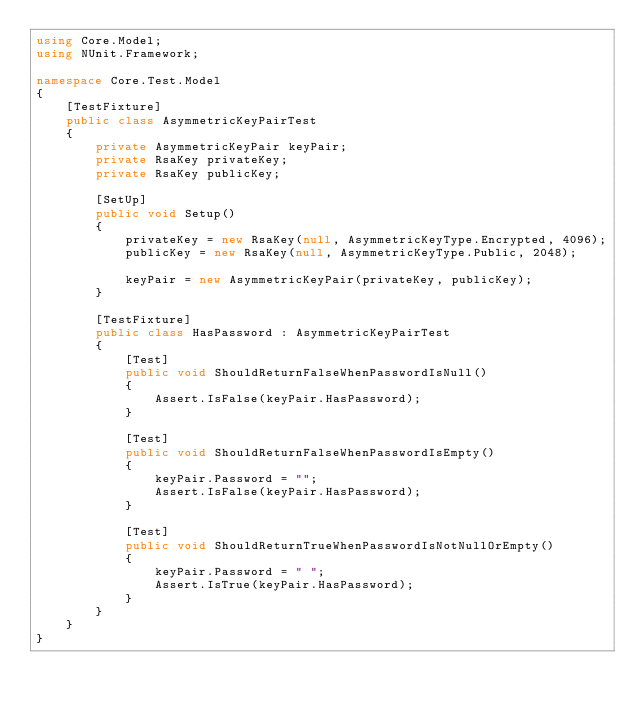Convert code to text. <code><loc_0><loc_0><loc_500><loc_500><_C#_>using Core.Model;
using NUnit.Framework;

namespace Core.Test.Model
{
    [TestFixture]
    public class AsymmetricKeyPairTest
    {
        private AsymmetricKeyPair keyPair;
        private RsaKey privateKey;
        private RsaKey publicKey;

        [SetUp]
        public void Setup()
        {
            privateKey = new RsaKey(null, AsymmetricKeyType.Encrypted, 4096);
            publicKey = new RsaKey(null, AsymmetricKeyType.Public, 2048);

            keyPair = new AsymmetricKeyPair(privateKey, publicKey);
        }

        [TestFixture]
        public class HasPassword : AsymmetricKeyPairTest
        {
            [Test]
            public void ShouldReturnFalseWhenPasswordIsNull()
            {
                Assert.IsFalse(keyPair.HasPassword);
            }

            [Test]
            public void ShouldReturnFalseWhenPasswordIsEmpty()
            {
                keyPair.Password = "";
                Assert.IsFalse(keyPair.HasPassword);
            }

            [Test]
            public void ShouldReturnTrueWhenPasswordIsNotNullOrEmpty()
            {
                keyPair.Password = " ";
                Assert.IsTrue(keyPair.HasPassword);
            }
        }
    }
}</code> 